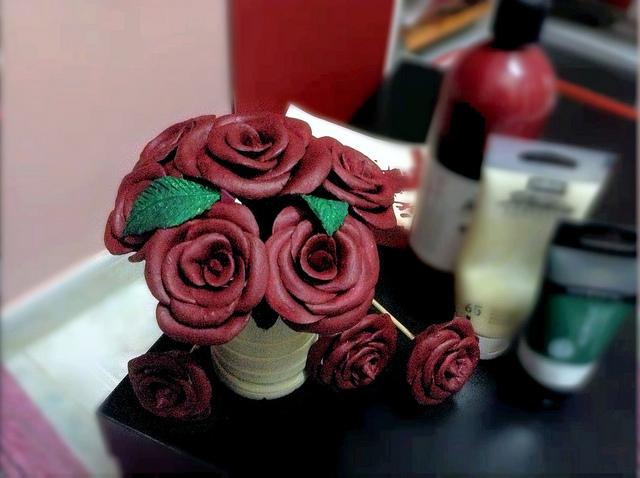What flower is with the rose?
Concise answer only. None. What type of rose are these?
Short answer required. Clay. Are the flowers made of clay?
Write a very short answer. Yes. Are the flowers real?
Concise answer only. No. What is the purpose of these flowers?
Concise answer only. Decoration. 